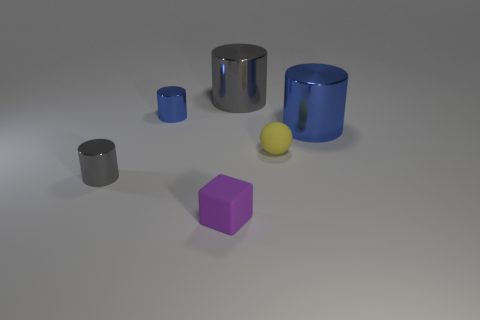There is a gray shiny cylinder that is right of the matte cube; does it have the same size as the small rubber block?
Your response must be concise. No. What is the material of the big gray cylinder?
Offer a very short reply. Metal. There is a thing that is on the right side of the block and to the left of the tiny yellow rubber thing; what material is it?
Offer a very short reply. Metal. What number of objects are either blue metallic objects on the right side of the big gray cylinder or gray metallic cylinders?
Ensure brevity in your answer.  3. Is the ball the same color as the small block?
Provide a short and direct response. No. Are there any other objects of the same size as the yellow thing?
Your response must be concise. Yes. How many small objects are both in front of the large blue cylinder and behind the small purple rubber thing?
Keep it short and to the point. 2. There is a rubber sphere; what number of large blue cylinders are right of it?
Provide a succinct answer. 1. Is there a yellow thing of the same shape as the large gray object?
Your answer should be compact. No. There is a tiny blue shiny thing; is its shape the same as the shiny object that is on the right side of the small yellow rubber thing?
Your answer should be very brief. Yes. 